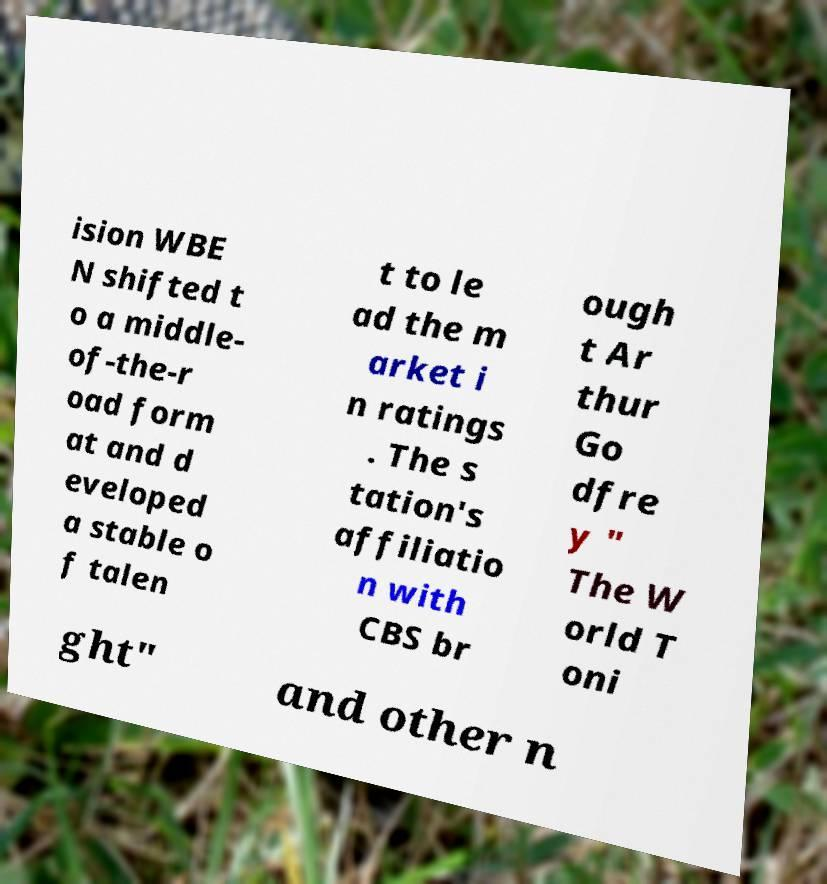Can you accurately transcribe the text from the provided image for me? ision WBE N shifted t o a middle- of-the-r oad form at and d eveloped a stable o f talen t to le ad the m arket i n ratings . The s tation's affiliatio n with CBS br ough t Ar thur Go dfre y " The W orld T oni ght" and other n 